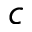<formula> <loc_0><loc_0><loc_500><loc_500>c</formula> 